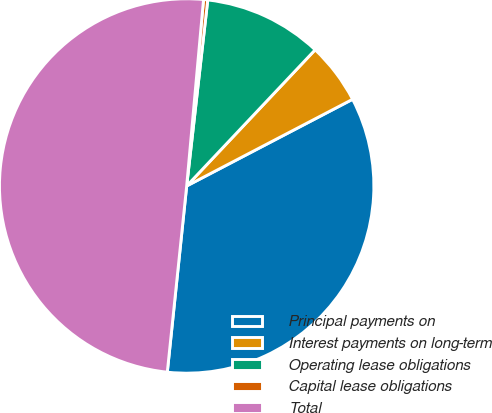Convert chart. <chart><loc_0><loc_0><loc_500><loc_500><pie_chart><fcel>Principal payments on<fcel>Interest payments on long-term<fcel>Operating lease obligations<fcel>Capital lease obligations<fcel>Total<nl><fcel>34.31%<fcel>5.3%<fcel>10.24%<fcel>0.36%<fcel>49.78%<nl></chart> 